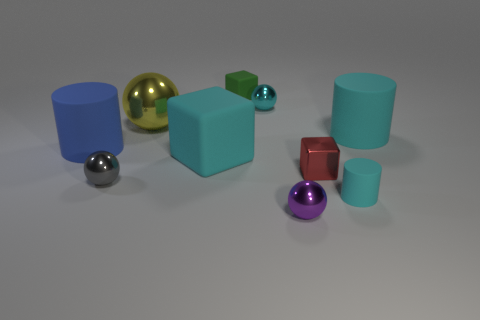Subtract all big cyan matte cylinders. How many cylinders are left? 2 Subtract all green cylinders. How many green cubes are left? 1 Subtract all blue cylinders. How many cylinders are left? 2 Subtract 1 yellow balls. How many objects are left? 9 Subtract all spheres. How many objects are left? 6 Subtract 2 cylinders. How many cylinders are left? 1 Subtract all red cubes. Subtract all gray cylinders. How many cubes are left? 2 Subtract all tiny purple metal objects. Subtract all big red rubber things. How many objects are left? 9 Add 4 large cyan matte cubes. How many large cyan matte cubes are left? 5 Add 9 cyan shiny blocks. How many cyan shiny blocks exist? 9 